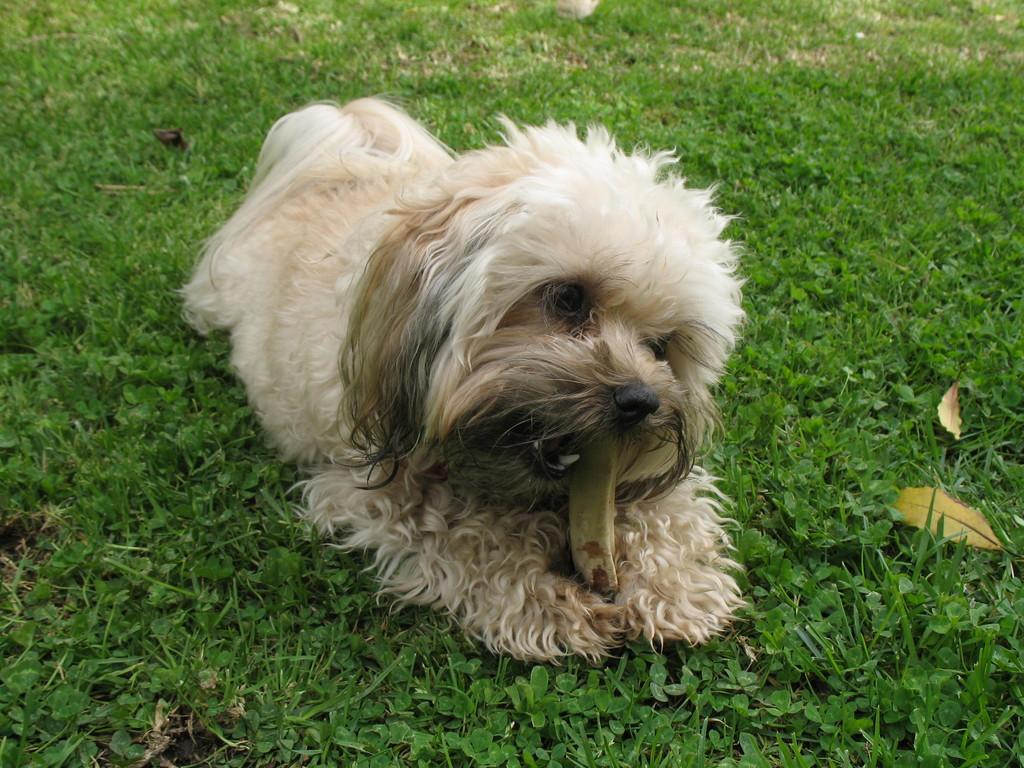What animal can be seen in the image? There is a dog in the image. What is the dog doing in the image? The dog is sitting on the ground. What is the dog holding in its mouth? The dog has an object in its mouth. What type of vegetation is present in the image? There are plants and grass in the image. What additional objects can be seen on the ground? There are dried leaves on the ground to the right. What type of guitar is the kitty playing in the image? There is no kitty or guitar present in the image; it features a dog sitting on the ground. Is the dog sitting inside a box in the image? There is no box present in the image; the dog is sitting on the ground. 